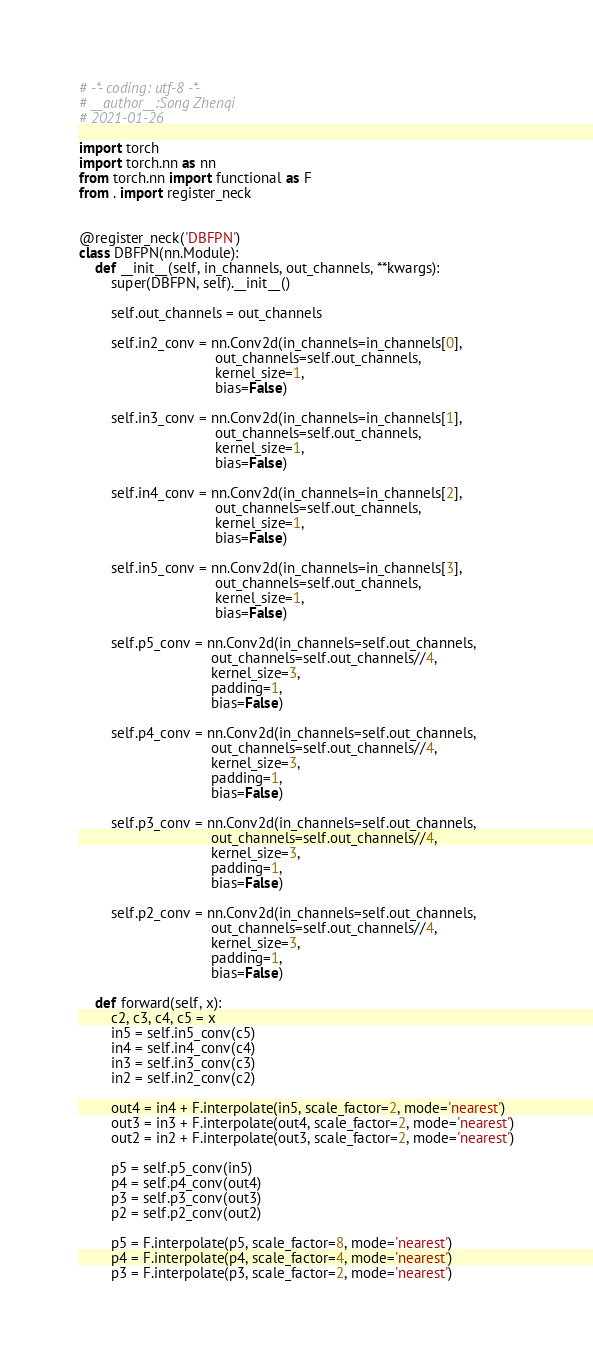<code> <loc_0><loc_0><loc_500><loc_500><_Python_># -*- coding: utf-8 -*-
# __author__:Song Zhenqi
# 2021-01-26

import torch
import torch.nn as nn
from torch.nn import functional as F
from . import register_neck


@register_neck('DBFPN')
class DBFPN(nn.Module):
    def __init__(self, in_channels, out_channels, **kwargs):
        super(DBFPN, self).__init__()

        self.out_channels = out_channels

        self.in2_conv = nn.Conv2d(in_channels=in_channels[0],
                                  out_channels=self.out_channels,
                                  kernel_size=1,
                                  bias=False)

        self.in3_conv = nn.Conv2d(in_channels=in_channels[1],
                                  out_channels=self.out_channels,
                                  kernel_size=1,
                                  bias=False)

        self.in4_conv = nn.Conv2d(in_channels=in_channels[2],
                                  out_channels=self.out_channels,
                                  kernel_size=1,
                                  bias=False)

        self.in5_conv = nn.Conv2d(in_channels=in_channels[3],
                                  out_channels=self.out_channels,
                                  kernel_size=1,
                                  bias=False)

        self.p5_conv = nn.Conv2d(in_channels=self.out_channels,
                                 out_channels=self.out_channels//4,
                                 kernel_size=3,
                                 padding=1,
                                 bias=False)

        self.p4_conv = nn.Conv2d(in_channels=self.out_channels,
                                 out_channels=self.out_channels//4,
                                 kernel_size=3,
                                 padding=1,
                                 bias=False)

        self.p3_conv = nn.Conv2d(in_channels=self.out_channels,
                                 out_channels=self.out_channels//4,
                                 kernel_size=3,
                                 padding=1,
                                 bias=False)

        self.p2_conv = nn.Conv2d(in_channels=self.out_channels,
                                 out_channels=self.out_channels//4,
                                 kernel_size=3,
                                 padding=1,
                                 bias=False)

    def forward(self, x):
        c2, c3, c4, c5 = x
        in5 = self.in5_conv(c5)
        in4 = self.in4_conv(c4)
        in3 = self.in3_conv(c3)
        in2 = self.in2_conv(c2)

        out4 = in4 + F.interpolate(in5, scale_factor=2, mode='nearest')
        out3 = in3 + F.interpolate(out4, scale_factor=2, mode='nearest')
        out2 = in2 + F.interpolate(out3, scale_factor=2, mode='nearest')

        p5 = self.p5_conv(in5)
        p4 = self.p4_conv(out4)
        p3 = self.p3_conv(out3)
        p2 = self.p2_conv(out2)

        p5 = F.interpolate(p5, scale_factor=8, mode='nearest')
        p4 = F.interpolate(p4, scale_factor=4, mode='nearest')
        p3 = F.interpolate(p3, scale_factor=2, mode='nearest')
</code> 